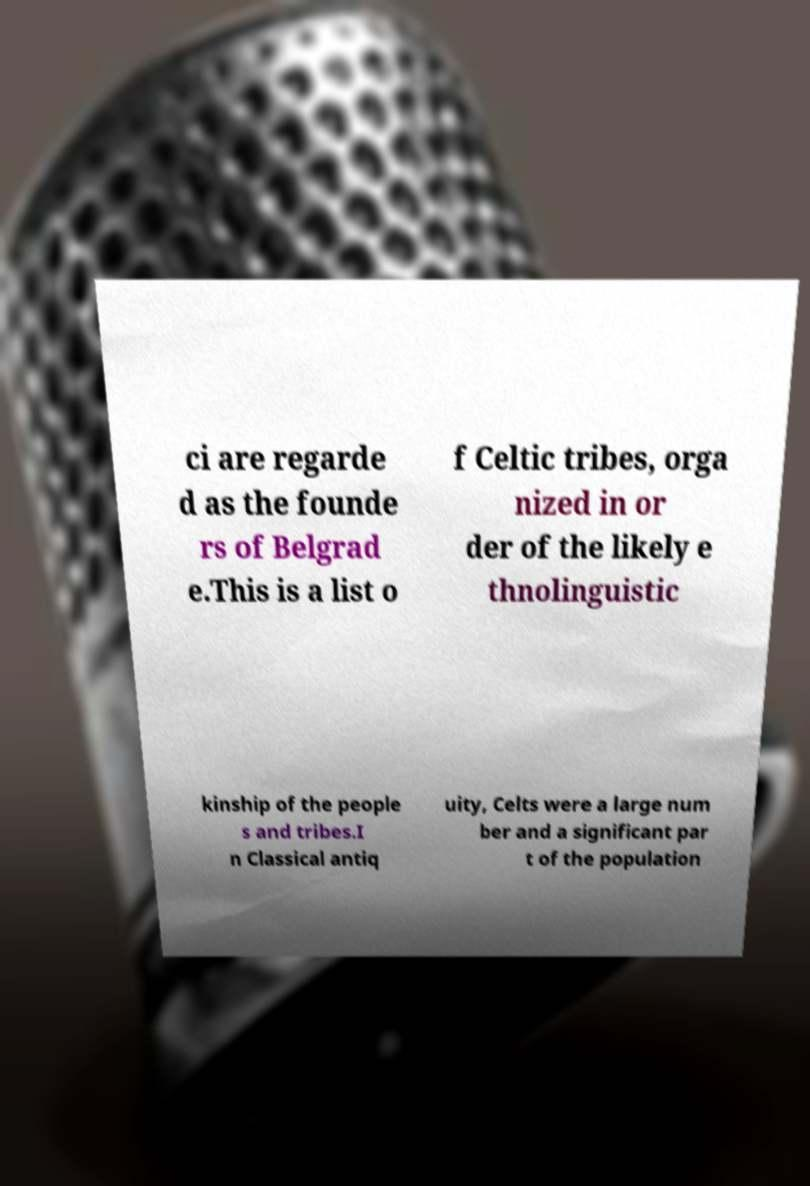What messages or text are displayed in this image? I need them in a readable, typed format. ci are regarde d as the founde rs of Belgrad e.This is a list o f Celtic tribes, orga nized in or der of the likely e thnolinguistic kinship of the people s and tribes.I n Classical antiq uity, Celts were a large num ber and a significant par t of the population 